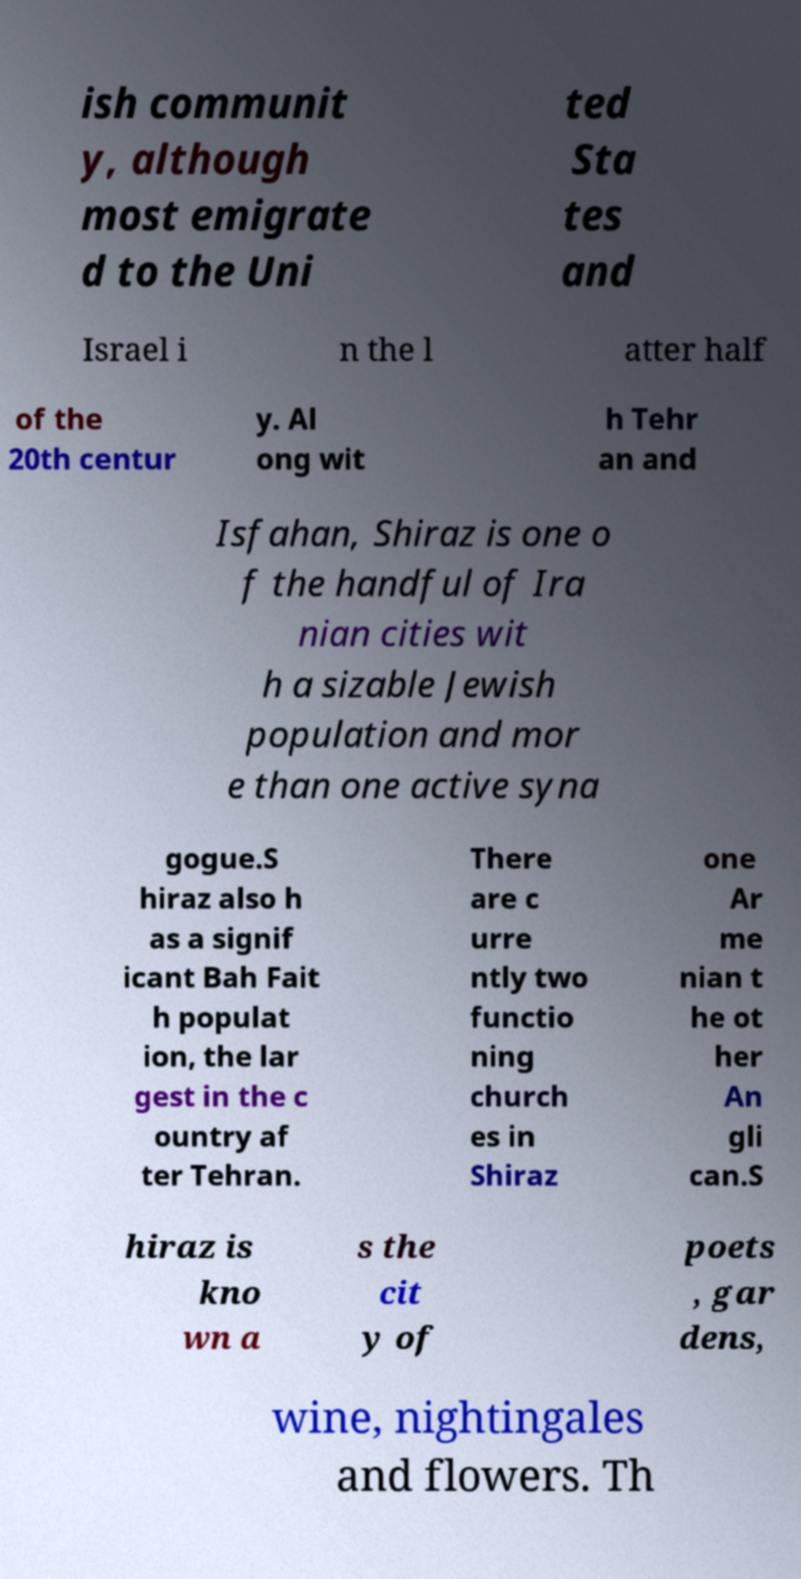Please identify and transcribe the text found in this image. ish communit y, although most emigrate d to the Uni ted Sta tes and Israel i n the l atter half of the 20th centur y. Al ong wit h Tehr an and Isfahan, Shiraz is one o f the handful of Ira nian cities wit h a sizable Jewish population and mor e than one active syna gogue.S hiraz also h as a signif icant Bah Fait h populat ion, the lar gest in the c ountry af ter Tehran. There are c urre ntly two functio ning church es in Shiraz one Ar me nian t he ot her An gli can.S hiraz is kno wn a s the cit y of poets , gar dens, wine, nightingales and flowers. Th 